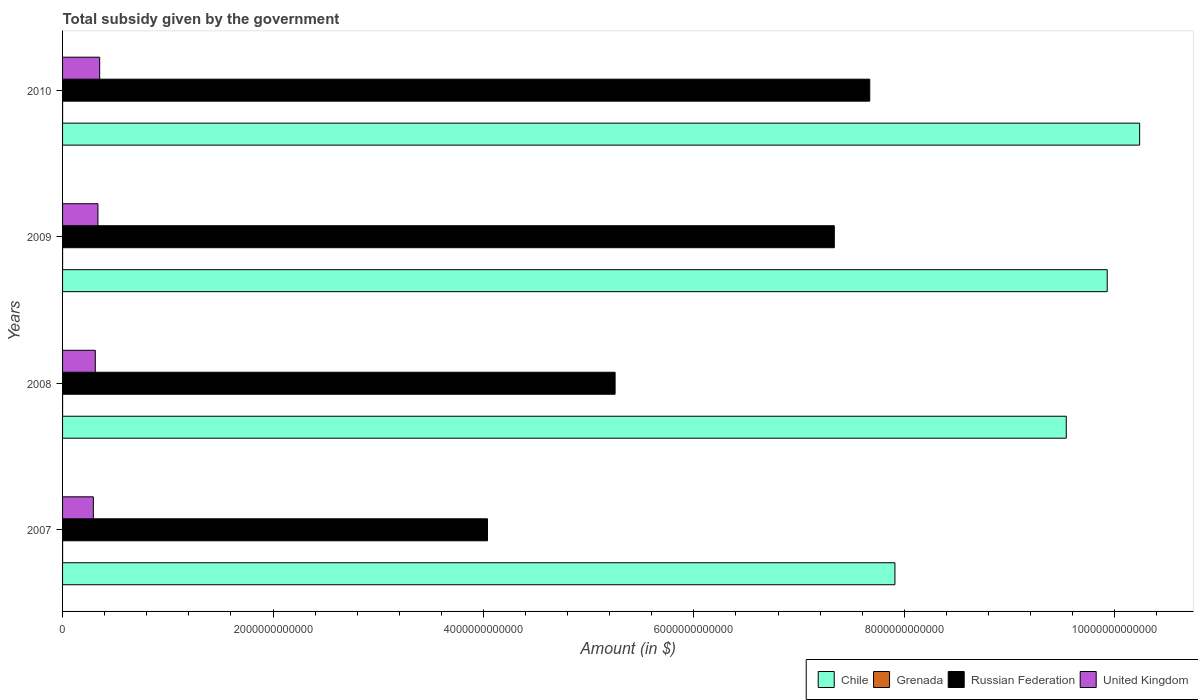How many different coloured bars are there?
Offer a terse response. 4. How many groups of bars are there?
Your answer should be very brief. 4. Are the number of bars per tick equal to the number of legend labels?
Provide a short and direct response. Yes. How many bars are there on the 4th tick from the bottom?
Your answer should be very brief. 4. What is the label of the 2nd group of bars from the top?
Your answer should be compact. 2009. What is the total revenue collected by the government in Russian Federation in 2010?
Provide a succinct answer. 7.67e+12. Across all years, what is the maximum total revenue collected by the government in Russian Federation?
Keep it short and to the point. 7.67e+12. Across all years, what is the minimum total revenue collected by the government in Russian Federation?
Ensure brevity in your answer.  4.04e+12. In which year was the total revenue collected by the government in Chile maximum?
Your answer should be compact. 2010. What is the total total revenue collected by the government in Russian Federation in the graph?
Your response must be concise. 2.43e+13. What is the difference between the total revenue collected by the government in Russian Federation in 2009 and that in 2010?
Your answer should be compact. -3.37e+11. What is the difference between the total revenue collected by the government in United Kingdom in 2010 and the total revenue collected by the government in Russian Federation in 2007?
Offer a terse response. -3.69e+12. What is the average total revenue collected by the government in Russian Federation per year?
Ensure brevity in your answer.  6.07e+12. In the year 2007, what is the difference between the total revenue collected by the government in United Kingdom and total revenue collected by the government in Chile?
Provide a succinct answer. -7.62e+12. In how many years, is the total revenue collected by the government in Russian Federation greater than 6400000000000 $?
Give a very brief answer. 2. What is the ratio of the total revenue collected by the government in United Kingdom in 2007 to that in 2010?
Give a very brief answer. 0.83. Is the total revenue collected by the government in United Kingdom in 2008 less than that in 2009?
Provide a short and direct response. Yes. Is the difference between the total revenue collected by the government in United Kingdom in 2007 and 2010 greater than the difference between the total revenue collected by the government in Chile in 2007 and 2010?
Ensure brevity in your answer.  Yes. What is the difference between the highest and the second highest total revenue collected by the government in United Kingdom?
Offer a terse response. 1.64e+1. What is the difference between the highest and the lowest total revenue collected by the government in Russian Federation?
Your answer should be compact. 3.63e+12. Is the sum of the total revenue collected by the government in United Kingdom in 2007 and 2010 greater than the maximum total revenue collected by the government in Chile across all years?
Your response must be concise. No. What does the 2nd bar from the top in 2007 represents?
Your response must be concise. Russian Federation. What does the 3rd bar from the bottom in 2008 represents?
Provide a short and direct response. Russian Federation. Are all the bars in the graph horizontal?
Ensure brevity in your answer.  Yes. How many years are there in the graph?
Your response must be concise. 4. What is the difference between two consecutive major ticks on the X-axis?
Keep it short and to the point. 2.00e+12. Are the values on the major ticks of X-axis written in scientific E-notation?
Provide a short and direct response. No. Does the graph contain grids?
Keep it short and to the point. No. Where does the legend appear in the graph?
Your answer should be compact. Bottom right. How many legend labels are there?
Provide a succinct answer. 4. How are the legend labels stacked?
Ensure brevity in your answer.  Horizontal. What is the title of the graph?
Provide a short and direct response. Total subsidy given by the government. Does "Lower middle income" appear as one of the legend labels in the graph?
Keep it short and to the point. No. What is the label or title of the X-axis?
Your answer should be very brief. Amount (in $). What is the Amount (in $) in Chile in 2007?
Provide a succinct answer. 7.91e+12. What is the Amount (in $) in Grenada in 2007?
Your answer should be very brief. 7.55e+07. What is the Amount (in $) in Russian Federation in 2007?
Ensure brevity in your answer.  4.04e+12. What is the Amount (in $) in United Kingdom in 2007?
Make the answer very short. 2.93e+11. What is the Amount (in $) of Chile in 2008?
Offer a terse response. 9.54e+12. What is the Amount (in $) in Grenada in 2008?
Make the answer very short. 9.32e+07. What is the Amount (in $) in Russian Federation in 2008?
Your answer should be very brief. 5.25e+12. What is the Amount (in $) in United Kingdom in 2008?
Make the answer very short. 3.11e+11. What is the Amount (in $) of Chile in 2009?
Your response must be concise. 9.93e+12. What is the Amount (in $) in Grenada in 2009?
Your answer should be very brief. 9.41e+07. What is the Amount (in $) in Russian Federation in 2009?
Your answer should be very brief. 7.33e+12. What is the Amount (in $) in United Kingdom in 2009?
Your answer should be compact. 3.36e+11. What is the Amount (in $) in Chile in 2010?
Provide a succinct answer. 1.02e+13. What is the Amount (in $) in Grenada in 2010?
Ensure brevity in your answer.  7.42e+07. What is the Amount (in $) of Russian Federation in 2010?
Give a very brief answer. 7.67e+12. What is the Amount (in $) of United Kingdom in 2010?
Provide a short and direct response. 3.53e+11. Across all years, what is the maximum Amount (in $) in Chile?
Offer a very short reply. 1.02e+13. Across all years, what is the maximum Amount (in $) of Grenada?
Provide a short and direct response. 9.41e+07. Across all years, what is the maximum Amount (in $) in Russian Federation?
Your answer should be very brief. 7.67e+12. Across all years, what is the maximum Amount (in $) in United Kingdom?
Your answer should be very brief. 3.53e+11. Across all years, what is the minimum Amount (in $) in Chile?
Ensure brevity in your answer.  7.91e+12. Across all years, what is the minimum Amount (in $) in Grenada?
Provide a succinct answer. 7.42e+07. Across all years, what is the minimum Amount (in $) in Russian Federation?
Your response must be concise. 4.04e+12. Across all years, what is the minimum Amount (in $) of United Kingdom?
Your answer should be very brief. 2.93e+11. What is the total Amount (in $) of Chile in the graph?
Offer a very short reply. 3.76e+13. What is the total Amount (in $) of Grenada in the graph?
Your response must be concise. 3.37e+08. What is the total Amount (in $) of Russian Federation in the graph?
Your response must be concise. 2.43e+13. What is the total Amount (in $) in United Kingdom in the graph?
Keep it short and to the point. 1.29e+12. What is the difference between the Amount (in $) of Chile in 2007 and that in 2008?
Offer a terse response. -1.63e+12. What is the difference between the Amount (in $) of Grenada in 2007 and that in 2008?
Keep it short and to the point. -1.77e+07. What is the difference between the Amount (in $) of Russian Federation in 2007 and that in 2008?
Make the answer very short. -1.21e+12. What is the difference between the Amount (in $) of United Kingdom in 2007 and that in 2008?
Make the answer very short. -1.86e+1. What is the difference between the Amount (in $) of Chile in 2007 and that in 2009?
Ensure brevity in your answer.  -2.02e+12. What is the difference between the Amount (in $) in Grenada in 2007 and that in 2009?
Keep it short and to the point. -1.86e+07. What is the difference between the Amount (in $) of Russian Federation in 2007 and that in 2009?
Provide a short and direct response. -3.30e+12. What is the difference between the Amount (in $) of United Kingdom in 2007 and that in 2009?
Make the answer very short. -4.38e+1. What is the difference between the Amount (in $) of Chile in 2007 and that in 2010?
Your answer should be compact. -2.33e+12. What is the difference between the Amount (in $) in Grenada in 2007 and that in 2010?
Your response must be concise. 1.30e+06. What is the difference between the Amount (in $) in Russian Federation in 2007 and that in 2010?
Keep it short and to the point. -3.63e+12. What is the difference between the Amount (in $) in United Kingdom in 2007 and that in 2010?
Keep it short and to the point. -6.02e+1. What is the difference between the Amount (in $) in Chile in 2008 and that in 2009?
Your answer should be compact. -3.89e+11. What is the difference between the Amount (in $) in Grenada in 2008 and that in 2009?
Make the answer very short. -9.00e+05. What is the difference between the Amount (in $) in Russian Federation in 2008 and that in 2009?
Offer a terse response. -2.08e+12. What is the difference between the Amount (in $) of United Kingdom in 2008 and that in 2009?
Your response must be concise. -2.52e+1. What is the difference between the Amount (in $) in Chile in 2008 and that in 2010?
Your response must be concise. -6.97e+11. What is the difference between the Amount (in $) in Grenada in 2008 and that in 2010?
Your answer should be very brief. 1.90e+07. What is the difference between the Amount (in $) in Russian Federation in 2008 and that in 2010?
Your answer should be compact. -2.42e+12. What is the difference between the Amount (in $) in United Kingdom in 2008 and that in 2010?
Keep it short and to the point. -4.16e+1. What is the difference between the Amount (in $) in Chile in 2009 and that in 2010?
Provide a short and direct response. -3.08e+11. What is the difference between the Amount (in $) in Grenada in 2009 and that in 2010?
Give a very brief answer. 1.99e+07. What is the difference between the Amount (in $) of Russian Federation in 2009 and that in 2010?
Your response must be concise. -3.37e+11. What is the difference between the Amount (in $) in United Kingdom in 2009 and that in 2010?
Your answer should be very brief. -1.64e+1. What is the difference between the Amount (in $) in Chile in 2007 and the Amount (in $) in Grenada in 2008?
Offer a terse response. 7.91e+12. What is the difference between the Amount (in $) in Chile in 2007 and the Amount (in $) in Russian Federation in 2008?
Make the answer very short. 2.66e+12. What is the difference between the Amount (in $) in Chile in 2007 and the Amount (in $) in United Kingdom in 2008?
Offer a very short reply. 7.60e+12. What is the difference between the Amount (in $) in Grenada in 2007 and the Amount (in $) in Russian Federation in 2008?
Provide a succinct answer. -5.25e+12. What is the difference between the Amount (in $) in Grenada in 2007 and the Amount (in $) in United Kingdom in 2008?
Your response must be concise. -3.11e+11. What is the difference between the Amount (in $) in Russian Federation in 2007 and the Amount (in $) in United Kingdom in 2008?
Ensure brevity in your answer.  3.73e+12. What is the difference between the Amount (in $) of Chile in 2007 and the Amount (in $) of Grenada in 2009?
Make the answer very short. 7.91e+12. What is the difference between the Amount (in $) in Chile in 2007 and the Amount (in $) in Russian Federation in 2009?
Give a very brief answer. 5.76e+11. What is the difference between the Amount (in $) in Chile in 2007 and the Amount (in $) in United Kingdom in 2009?
Give a very brief answer. 7.57e+12. What is the difference between the Amount (in $) of Grenada in 2007 and the Amount (in $) of Russian Federation in 2009?
Keep it short and to the point. -7.33e+12. What is the difference between the Amount (in $) in Grenada in 2007 and the Amount (in $) in United Kingdom in 2009?
Your answer should be very brief. -3.36e+11. What is the difference between the Amount (in $) of Russian Federation in 2007 and the Amount (in $) of United Kingdom in 2009?
Your answer should be very brief. 3.70e+12. What is the difference between the Amount (in $) in Chile in 2007 and the Amount (in $) in Grenada in 2010?
Your answer should be very brief. 7.91e+12. What is the difference between the Amount (in $) in Chile in 2007 and the Amount (in $) in Russian Federation in 2010?
Your answer should be compact. 2.39e+11. What is the difference between the Amount (in $) of Chile in 2007 and the Amount (in $) of United Kingdom in 2010?
Offer a very short reply. 7.56e+12. What is the difference between the Amount (in $) in Grenada in 2007 and the Amount (in $) in Russian Federation in 2010?
Ensure brevity in your answer.  -7.67e+12. What is the difference between the Amount (in $) in Grenada in 2007 and the Amount (in $) in United Kingdom in 2010?
Provide a short and direct response. -3.53e+11. What is the difference between the Amount (in $) of Russian Federation in 2007 and the Amount (in $) of United Kingdom in 2010?
Make the answer very short. 3.69e+12. What is the difference between the Amount (in $) of Chile in 2008 and the Amount (in $) of Grenada in 2009?
Provide a succinct answer. 9.54e+12. What is the difference between the Amount (in $) of Chile in 2008 and the Amount (in $) of Russian Federation in 2009?
Make the answer very short. 2.20e+12. What is the difference between the Amount (in $) in Chile in 2008 and the Amount (in $) in United Kingdom in 2009?
Ensure brevity in your answer.  9.20e+12. What is the difference between the Amount (in $) of Grenada in 2008 and the Amount (in $) of Russian Federation in 2009?
Ensure brevity in your answer.  -7.33e+12. What is the difference between the Amount (in $) of Grenada in 2008 and the Amount (in $) of United Kingdom in 2009?
Your answer should be very brief. -3.36e+11. What is the difference between the Amount (in $) of Russian Federation in 2008 and the Amount (in $) of United Kingdom in 2009?
Your response must be concise. 4.91e+12. What is the difference between the Amount (in $) of Chile in 2008 and the Amount (in $) of Grenada in 2010?
Provide a short and direct response. 9.54e+12. What is the difference between the Amount (in $) in Chile in 2008 and the Amount (in $) in Russian Federation in 2010?
Your answer should be compact. 1.87e+12. What is the difference between the Amount (in $) in Chile in 2008 and the Amount (in $) in United Kingdom in 2010?
Your answer should be very brief. 9.19e+12. What is the difference between the Amount (in $) of Grenada in 2008 and the Amount (in $) of Russian Federation in 2010?
Give a very brief answer. -7.67e+12. What is the difference between the Amount (in $) in Grenada in 2008 and the Amount (in $) in United Kingdom in 2010?
Provide a short and direct response. -3.53e+11. What is the difference between the Amount (in $) in Russian Federation in 2008 and the Amount (in $) in United Kingdom in 2010?
Give a very brief answer. 4.90e+12. What is the difference between the Amount (in $) of Chile in 2009 and the Amount (in $) of Grenada in 2010?
Make the answer very short. 9.93e+12. What is the difference between the Amount (in $) in Chile in 2009 and the Amount (in $) in Russian Federation in 2010?
Make the answer very short. 2.26e+12. What is the difference between the Amount (in $) in Chile in 2009 and the Amount (in $) in United Kingdom in 2010?
Your response must be concise. 9.58e+12. What is the difference between the Amount (in $) in Grenada in 2009 and the Amount (in $) in Russian Federation in 2010?
Provide a short and direct response. -7.67e+12. What is the difference between the Amount (in $) in Grenada in 2009 and the Amount (in $) in United Kingdom in 2010?
Ensure brevity in your answer.  -3.53e+11. What is the difference between the Amount (in $) in Russian Federation in 2009 and the Amount (in $) in United Kingdom in 2010?
Provide a short and direct response. 6.98e+12. What is the average Amount (in $) of Chile per year?
Provide a short and direct response. 9.40e+12. What is the average Amount (in $) in Grenada per year?
Your answer should be very brief. 8.42e+07. What is the average Amount (in $) of Russian Federation per year?
Offer a terse response. 6.07e+12. What is the average Amount (in $) in United Kingdom per year?
Offer a terse response. 3.23e+11. In the year 2007, what is the difference between the Amount (in $) of Chile and Amount (in $) of Grenada?
Provide a short and direct response. 7.91e+12. In the year 2007, what is the difference between the Amount (in $) in Chile and Amount (in $) in Russian Federation?
Give a very brief answer. 3.87e+12. In the year 2007, what is the difference between the Amount (in $) in Chile and Amount (in $) in United Kingdom?
Offer a terse response. 7.62e+12. In the year 2007, what is the difference between the Amount (in $) in Grenada and Amount (in $) in Russian Federation?
Keep it short and to the point. -4.04e+12. In the year 2007, what is the difference between the Amount (in $) in Grenada and Amount (in $) in United Kingdom?
Provide a short and direct response. -2.92e+11. In the year 2007, what is the difference between the Amount (in $) of Russian Federation and Amount (in $) of United Kingdom?
Keep it short and to the point. 3.75e+12. In the year 2008, what is the difference between the Amount (in $) of Chile and Amount (in $) of Grenada?
Your answer should be compact. 9.54e+12. In the year 2008, what is the difference between the Amount (in $) in Chile and Amount (in $) in Russian Federation?
Ensure brevity in your answer.  4.29e+12. In the year 2008, what is the difference between the Amount (in $) in Chile and Amount (in $) in United Kingdom?
Keep it short and to the point. 9.23e+12. In the year 2008, what is the difference between the Amount (in $) in Grenada and Amount (in $) in Russian Federation?
Offer a very short reply. -5.25e+12. In the year 2008, what is the difference between the Amount (in $) in Grenada and Amount (in $) in United Kingdom?
Ensure brevity in your answer.  -3.11e+11. In the year 2008, what is the difference between the Amount (in $) of Russian Federation and Amount (in $) of United Kingdom?
Give a very brief answer. 4.94e+12. In the year 2009, what is the difference between the Amount (in $) of Chile and Amount (in $) of Grenada?
Keep it short and to the point. 9.93e+12. In the year 2009, what is the difference between the Amount (in $) in Chile and Amount (in $) in Russian Federation?
Give a very brief answer. 2.59e+12. In the year 2009, what is the difference between the Amount (in $) in Chile and Amount (in $) in United Kingdom?
Give a very brief answer. 9.59e+12. In the year 2009, what is the difference between the Amount (in $) of Grenada and Amount (in $) of Russian Federation?
Give a very brief answer. -7.33e+12. In the year 2009, what is the difference between the Amount (in $) of Grenada and Amount (in $) of United Kingdom?
Give a very brief answer. -3.36e+11. In the year 2009, what is the difference between the Amount (in $) in Russian Federation and Amount (in $) in United Kingdom?
Provide a succinct answer. 7.00e+12. In the year 2010, what is the difference between the Amount (in $) of Chile and Amount (in $) of Grenada?
Make the answer very short. 1.02e+13. In the year 2010, what is the difference between the Amount (in $) in Chile and Amount (in $) in Russian Federation?
Offer a terse response. 2.56e+12. In the year 2010, what is the difference between the Amount (in $) of Chile and Amount (in $) of United Kingdom?
Provide a succinct answer. 9.88e+12. In the year 2010, what is the difference between the Amount (in $) of Grenada and Amount (in $) of Russian Federation?
Offer a very short reply. -7.67e+12. In the year 2010, what is the difference between the Amount (in $) in Grenada and Amount (in $) in United Kingdom?
Give a very brief answer. -3.53e+11. In the year 2010, what is the difference between the Amount (in $) of Russian Federation and Amount (in $) of United Kingdom?
Keep it short and to the point. 7.32e+12. What is the ratio of the Amount (in $) in Chile in 2007 to that in 2008?
Provide a short and direct response. 0.83. What is the ratio of the Amount (in $) in Grenada in 2007 to that in 2008?
Ensure brevity in your answer.  0.81. What is the ratio of the Amount (in $) in Russian Federation in 2007 to that in 2008?
Offer a very short reply. 0.77. What is the ratio of the Amount (in $) of United Kingdom in 2007 to that in 2008?
Provide a short and direct response. 0.94. What is the ratio of the Amount (in $) in Chile in 2007 to that in 2009?
Provide a short and direct response. 0.8. What is the ratio of the Amount (in $) in Grenada in 2007 to that in 2009?
Ensure brevity in your answer.  0.8. What is the ratio of the Amount (in $) of Russian Federation in 2007 to that in 2009?
Keep it short and to the point. 0.55. What is the ratio of the Amount (in $) in United Kingdom in 2007 to that in 2009?
Ensure brevity in your answer.  0.87. What is the ratio of the Amount (in $) in Chile in 2007 to that in 2010?
Your response must be concise. 0.77. What is the ratio of the Amount (in $) in Grenada in 2007 to that in 2010?
Offer a very short reply. 1.02. What is the ratio of the Amount (in $) of Russian Federation in 2007 to that in 2010?
Provide a succinct answer. 0.53. What is the ratio of the Amount (in $) in United Kingdom in 2007 to that in 2010?
Keep it short and to the point. 0.83. What is the ratio of the Amount (in $) of Chile in 2008 to that in 2009?
Give a very brief answer. 0.96. What is the ratio of the Amount (in $) in Grenada in 2008 to that in 2009?
Offer a terse response. 0.99. What is the ratio of the Amount (in $) of Russian Federation in 2008 to that in 2009?
Give a very brief answer. 0.72. What is the ratio of the Amount (in $) of United Kingdom in 2008 to that in 2009?
Your response must be concise. 0.93. What is the ratio of the Amount (in $) in Chile in 2008 to that in 2010?
Ensure brevity in your answer.  0.93. What is the ratio of the Amount (in $) of Grenada in 2008 to that in 2010?
Your answer should be very brief. 1.26. What is the ratio of the Amount (in $) of Russian Federation in 2008 to that in 2010?
Offer a very short reply. 0.68. What is the ratio of the Amount (in $) in United Kingdom in 2008 to that in 2010?
Keep it short and to the point. 0.88. What is the ratio of the Amount (in $) of Chile in 2009 to that in 2010?
Your answer should be compact. 0.97. What is the ratio of the Amount (in $) in Grenada in 2009 to that in 2010?
Make the answer very short. 1.27. What is the ratio of the Amount (in $) of Russian Federation in 2009 to that in 2010?
Your response must be concise. 0.96. What is the ratio of the Amount (in $) of United Kingdom in 2009 to that in 2010?
Provide a short and direct response. 0.95. What is the difference between the highest and the second highest Amount (in $) in Chile?
Make the answer very short. 3.08e+11. What is the difference between the highest and the second highest Amount (in $) of Grenada?
Give a very brief answer. 9.00e+05. What is the difference between the highest and the second highest Amount (in $) of Russian Federation?
Your answer should be very brief. 3.37e+11. What is the difference between the highest and the second highest Amount (in $) in United Kingdom?
Your answer should be compact. 1.64e+1. What is the difference between the highest and the lowest Amount (in $) of Chile?
Provide a succinct answer. 2.33e+12. What is the difference between the highest and the lowest Amount (in $) in Grenada?
Provide a short and direct response. 1.99e+07. What is the difference between the highest and the lowest Amount (in $) of Russian Federation?
Your answer should be compact. 3.63e+12. What is the difference between the highest and the lowest Amount (in $) of United Kingdom?
Your response must be concise. 6.02e+1. 